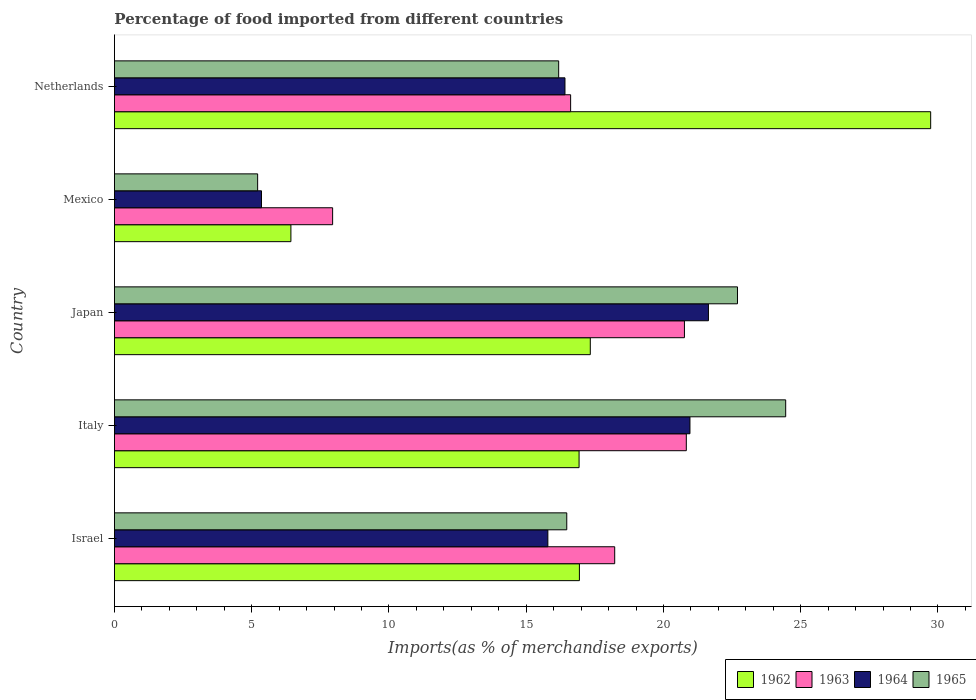How many different coloured bars are there?
Your response must be concise. 4. Are the number of bars on each tick of the Y-axis equal?
Offer a very short reply. Yes. How many bars are there on the 2nd tick from the top?
Give a very brief answer. 4. How many bars are there on the 3rd tick from the bottom?
Give a very brief answer. 4. In how many cases, is the number of bars for a given country not equal to the number of legend labels?
Give a very brief answer. 0. What is the percentage of imports to different countries in 1963 in Israel?
Offer a terse response. 18.22. Across all countries, what is the maximum percentage of imports to different countries in 1965?
Your response must be concise. 24.45. Across all countries, what is the minimum percentage of imports to different countries in 1965?
Ensure brevity in your answer.  5.22. In which country was the percentage of imports to different countries in 1965 minimum?
Offer a very short reply. Mexico. What is the total percentage of imports to different countries in 1964 in the graph?
Provide a succinct answer. 80.16. What is the difference between the percentage of imports to different countries in 1962 in Mexico and that in Netherlands?
Keep it short and to the point. -23.31. What is the difference between the percentage of imports to different countries in 1965 in Italy and the percentage of imports to different countries in 1964 in Netherlands?
Your answer should be very brief. 8.04. What is the average percentage of imports to different countries in 1965 per country?
Provide a short and direct response. 17.01. What is the difference between the percentage of imports to different countries in 1962 and percentage of imports to different countries in 1963 in Italy?
Your answer should be very brief. -3.91. What is the ratio of the percentage of imports to different countries in 1964 in Israel to that in Mexico?
Your answer should be very brief. 2.95. What is the difference between the highest and the second highest percentage of imports to different countries in 1965?
Provide a succinct answer. 1.76. What is the difference between the highest and the lowest percentage of imports to different countries in 1965?
Ensure brevity in your answer.  19.24. In how many countries, is the percentage of imports to different countries in 1962 greater than the average percentage of imports to different countries in 1962 taken over all countries?
Ensure brevity in your answer.  1. What does the 3rd bar from the top in Netherlands represents?
Provide a succinct answer. 1963. What does the 3rd bar from the bottom in Mexico represents?
Make the answer very short. 1964. How many bars are there?
Your response must be concise. 20. Are all the bars in the graph horizontal?
Give a very brief answer. Yes. Are the values on the major ticks of X-axis written in scientific E-notation?
Make the answer very short. No. Does the graph contain grids?
Offer a very short reply. No. Where does the legend appear in the graph?
Your response must be concise. Bottom right. How many legend labels are there?
Give a very brief answer. 4. How are the legend labels stacked?
Make the answer very short. Horizontal. What is the title of the graph?
Your response must be concise. Percentage of food imported from different countries. What is the label or title of the X-axis?
Provide a short and direct response. Imports(as % of merchandise exports). What is the label or title of the Y-axis?
Ensure brevity in your answer.  Country. What is the Imports(as % of merchandise exports) in 1962 in Israel?
Give a very brief answer. 16.94. What is the Imports(as % of merchandise exports) of 1963 in Israel?
Your answer should be very brief. 18.22. What is the Imports(as % of merchandise exports) of 1964 in Israel?
Your answer should be compact. 15.79. What is the Imports(as % of merchandise exports) of 1965 in Israel?
Ensure brevity in your answer.  16.48. What is the Imports(as % of merchandise exports) in 1962 in Italy?
Your answer should be very brief. 16.93. What is the Imports(as % of merchandise exports) of 1963 in Italy?
Your answer should be very brief. 20.83. What is the Imports(as % of merchandise exports) of 1964 in Italy?
Make the answer very short. 20.97. What is the Imports(as % of merchandise exports) of 1965 in Italy?
Give a very brief answer. 24.45. What is the Imports(as % of merchandise exports) in 1962 in Japan?
Provide a succinct answer. 17.34. What is the Imports(as % of merchandise exports) in 1963 in Japan?
Your response must be concise. 20.76. What is the Imports(as % of merchandise exports) of 1964 in Japan?
Provide a short and direct response. 21.64. What is the Imports(as % of merchandise exports) of 1965 in Japan?
Ensure brevity in your answer.  22.7. What is the Imports(as % of merchandise exports) of 1962 in Mexico?
Provide a short and direct response. 6.43. What is the Imports(as % of merchandise exports) in 1963 in Mexico?
Your answer should be compact. 7.95. What is the Imports(as % of merchandise exports) of 1964 in Mexico?
Give a very brief answer. 5.36. What is the Imports(as % of merchandise exports) of 1965 in Mexico?
Your answer should be compact. 5.22. What is the Imports(as % of merchandise exports) of 1962 in Netherlands?
Your response must be concise. 29.73. What is the Imports(as % of merchandise exports) of 1963 in Netherlands?
Offer a terse response. 16.62. What is the Imports(as % of merchandise exports) of 1964 in Netherlands?
Offer a very short reply. 16.41. What is the Imports(as % of merchandise exports) of 1965 in Netherlands?
Offer a very short reply. 16.18. Across all countries, what is the maximum Imports(as % of merchandise exports) in 1962?
Provide a short and direct response. 29.73. Across all countries, what is the maximum Imports(as % of merchandise exports) of 1963?
Offer a very short reply. 20.83. Across all countries, what is the maximum Imports(as % of merchandise exports) of 1964?
Your answer should be very brief. 21.64. Across all countries, what is the maximum Imports(as % of merchandise exports) of 1965?
Offer a very short reply. 24.45. Across all countries, what is the minimum Imports(as % of merchandise exports) in 1962?
Give a very brief answer. 6.43. Across all countries, what is the minimum Imports(as % of merchandise exports) of 1963?
Your response must be concise. 7.95. Across all countries, what is the minimum Imports(as % of merchandise exports) of 1964?
Provide a short and direct response. 5.36. Across all countries, what is the minimum Imports(as % of merchandise exports) of 1965?
Provide a succinct answer. 5.22. What is the total Imports(as % of merchandise exports) in 1962 in the graph?
Ensure brevity in your answer.  87.36. What is the total Imports(as % of merchandise exports) of 1963 in the graph?
Offer a terse response. 84.39. What is the total Imports(as % of merchandise exports) of 1964 in the graph?
Make the answer very short. 80.16. What is the total Imports(as % of merchandise exports) of 1965 in the graph?
Give a very brief answer. 85.03. What is the difference between the Imports(as % of merchandise exports) of 1962 in Israel and that in Italy?
Ensure brevity in your answer.  0.01. What is the difference between the Imports(as % of merchandise exports) in 1963 in Israel and that in Italy?
Your answer should be very brief. -2.61. What is the difference between the Imports(as % of merchandise exports) in 1964 in Israel and that in Italy?
Provide a succinct answer. -5.18. What is the difference between the Imports(as % of merchandise exports) in 1965 in Israel and that in Italy?
Keep it short and to the point. -7.97. What is the difference between the Imports(as % of merchandise exports) in 1962 in Israel and that in Japan?
Provide a short and direct response. -0.4. What is the difference between the Imports(as % of merchandise exports) of 1963 in Israel and that in Japan?
Keep it short and to the point. -2.54. What is the difference between the Imports(as % of merchandise exports) in 1964 in Israel and that in Japan?
Your answer should be very brief. -5.85. What is the difference between the Imports(as % of merchandise exports) of 1965 in Israel and that in Japan?
Ensure brevity in your answer.  -6.22. What is the difference between the Imports(as % of merchandise exports) of 1962 in Israel and that in Mexico?
Provide a short and direct response. 10.51. What is the difference between the Imports(as % of merchandise exports) of 1963 in Israel and that in Mexico?
Give a very brief answer. 10.28. What is the difference between the Imports(as % of merchandise exports) of 1964 in Israel and that in Mexico?
Make the answer very short. 10.43. What is the difference between the Imports(as % of merchandise exports) of 1965 in Israel and that in Mexico?
Your answer should be compact. 11.26. What is the difference between the Imports(as % of merchandise exports) of 1962 in Israel and that in Netherlands?
Make the answer very short. -12.8. What is the difference between the Imports(as % of merchandise exports) in 1963 in Israel and that in Netherlands?
Keep it short and to the point. 1.61. What is the difference between the Imports(as % of merchandise exports) of 1964 in Israel and that in Netherlands?
Give a very brief answer. -0.62. What is the difference between the Imports(as % of merchandise exports) of 1965 in Israel and that in Netherlands?
Give a very brief answer. 0.3. What is the difference between the Imports(as % of merchandise exports) of 1962 in Italy and that in Japan?
Offer a terse response. -0.41. What is the difference between the Imports(as % of merchandise exports) of 1963 in Italy and that in Japan?
Keep it short and to the point. 0.07. What is the difference between the Imports(as % of merchandise exports) of 1964 in Italy and that in Japan?
Make the answer very short. -0.67. What is the difference between the Imports(as % of merchandise exports) in 1965 in Italy and that in Japan?
Keep it short and to the point. 1.76. What is the difference between the Imports(as % of merchandise exports) of 1962 in Italy and that in Mexico?
Your answer should be very brief. 10.5. What is the difference between the Imports(as % of merchandise exports) of 1963 in Italy and that in Mexico?
Ensure brevity in your answer.  12.88. What is the difference between the Imports(as % of merchandise exports) of 1964 in Italy and that in Mexico?
Your answer should be compact. 15.61. What is the difference between the Imports(as % of merchandise exports) in 1965 in Italy and that in Mexico?
Provide a short and direct response. 19.24. What is the difference between the Imports(as % of merchandise exports) of 1962 in Italy and that in Netherlands?
Your answer should be compact. -12.81. What is the difference between the Imports(as % of merchandise exports) of 1963 in Italy and that in Netherlands?
Make the answer very short. 4.21. What is the difference between the Imports(as % of merchandise exports) of 1964 in Italy and that in Netherlands?
Make the answer very short. 4.55. What is the difference between the Imports(as % of merchandise exports) in 1965 in Italy and that in Netherlands?
Your answer should be compact. 8.27. What is the difference between the Imports(as % of merchandise exports) in 1962 in Japan and that in Mexico?
Your response must be concise. 10.91. What is the difference between the Imports(as % of merchandise exports) in 1963 in Japan and that in Mexico?
Your answer should be very brief. 12.82. What is the difference between the Imports(as % of merchandise exports) of 1964 in Japan and that in Mexico?
Offer a very short reply. 16.28. What is the difference between the Imports(as % of merchandise exports) of 1965 in Japan and that in Mexico?
Offer a terse response. 17.48. What is the difference between the Imports(as % of merchandise exports) of 1962 in Japan and that in Netherlands?
Offer a terse response. -12.4. What is the difference between the Imports(as % of merchandise exports) of 1963 in Japan and that in Netherlands?
Your answer should be very brief. 4.15. What is the difference between the Imports(as % of merchandise exports) in 1964 in Japan and that in Netherlands?
Provide a succinct answer. 5.23. What is the difference between the Imports(as % of merchandise exports) of 1965 in Japan and that in Netherlands?
Your answer should be very brief. 6.51. What is the difference between the Imports(as % of merchandise exports) of 1962 in Mexico and that in Netherlands?
Keep it short and to the point. -23.31. What is the difference between the Imports(as % of merchandise exports) in 1963 in Mexico and that in Netherlands?
Provide a short and direct response. -8.67. What is the difference between the Imports(as % of merchandise exports) of 1964 in Mexico and that in Netherlands?
Your answer should be very brief. -11.05. What is the difference between the Imports(as % of merchandise exports) in 1965 in Mexico and that in Netherlands?
Offer a very short reply. -10.97. What is the difference between the Imports(as % of merchandise exports) in 1962 in Israel and the Imports(as % of merchandise exports) in 1963 in Italy?
Keep it short and to the point. -3.89. What is the difference between the Imports(as % of merchandise exports) of 1962 in Israel and the Imports(as % of merchandise exports) of 1964 in Italy?
Give a very brief answer. -4.03. What is the difference between the Imports(as % of merchandise exports) of 1962 in Israel and the Imports(as % of merchandise exports) of 1965 in Italy?
Your answer should be very brief. -7.51. What is the difference between the Imports(as % of merchandise exports) in 1963 in Israel and the Imports(as % of merchandise exports) in 1964 in Italy?
Make the answer very short. -2.74. What is the difference between the Imports(as % of merchandise exports) of 1963 in Israel and the Imports(as % of merchandise exports) of 1965 in Italy?
Provide a short and direct response. -6.23. What is the difference between the Imports(as % of merchandise exports) in 1964 in Israel and the Imports(as % of merchandise exports) in 1965 in Italy?
Ensure brevity in your answer.  -8.66. What is the difference between the Imports(as % of merchandise exports) of 1962 in Israel and the Imports(as % of merchandise exports) of 1963 in Japan?
Your answer should be very brief. -3.83. What is the difference between the Imports(as % of merchandise exports) of 1962 in Israel and the Imports(as % of merchandise exports) of 1964 in Japan?
Your answer should be compact. -4.7. What is the difference between the Imports(as % of merchandise exports) in 1962 in Israel and the Imports(as % of merchandise exports) in 1965 in Japan?
Provide a short and direct response. -5.76. What is the difference between the Imports(as % of merchandise exports) in 1963 in Israel and the Imports(as % of merchandise exports) in 1964 in Japan?
Your answer should be compact. -3.41. What is the difference between the Imports(as % of merchandise exports) of 1963 in Israel and the Imports(as % of merchandise exports) of 1965 in Japan?
Provide a succinct answer. -4.47. What is the difference between the Imports(as % of merchandise exports) in 1964 in Israel and the Imports(as % of merchandise exports) in 1965 in Japan?
Offer a very short reply. -6.91. What is the difference between the Imports(as % of merchandise exports) in 1962 in Israel and the Imports(as % of merchandise exports) in 1963 in Mexico?
Make the answer very short. 8.99. What is the difference between the Imports(as % of merchandise exports) of 1962 in Israel and the Imports(as % of merchandise exports) of 1964 in Mexico?
Your response must be concise. 11.58. What is the difference between the Imports(as % of merchandise exports) in 1962 in Israel and the Imports(as % of merchandise exports) in 1965 in Mexico?
Offer a very short reply. 11.72. What is the difference between the Imports(as % of merchandise exports) of 1963 in Israel and the Imports(as % of merchandise exports) of 1964 in Mexico?
Provide a short and direct response. 12.87. What is the difference between the Imports(as % of merchandise exports) in 1963 in Israel and the Imports(as % of merchandise exports) in 1965 in Mexico?
Your response must be concise. 13.01. What is the difference between the Imports(as % of merchandise exports) in 1964 in Israel and the Imports(as % of merchandise exports) in 1965 in Mexico?
Give a very brief answer. 10.57. What is the difference between the Imports(as % of merchandise exports) of 1962 in Israel and the Imports(as % of merchandise exports) of 1963 in Netherlands?
Your answer should be compact. 0.32. What is the difference between the Imports(as % of merchandise exports) of 1962 in Israel and the Imports(as % of merchandise exports) of 1964 in Netherlands?
Ensure brevity in your answer.  0.53. What is the difference between the Imports(as % of merchandise exports) in 1962 in Israel and the Imports(as % of merchandise exports) in 1965 in Netherlands?
Offer a very short reply. 0.76. What is the difference between the Imports(as % of merchandise exports) of 1963 in Israel and the Imports(as % of merchandise exports) of 1964 in Netherlands?
Give a very brief answer. 1.81. What is the difference between the Imports(as % of merchandise exports) of 1963 in Israel and the Imports(as % of merchandise exports) of 1965 in Netherlands?
Your answer should be compact. 2.04. What is the difference between the Imports(as % of merchandise exports) of 1964 in Israel and the Imports(as % of merchandise exports) of 1965 in Netherlands?
Your answer should be compact. -0.39. What is the difference between the Imports(as % of merchandise exports) of 1962 in Italy and the Imports(as % of merchandise exports) of 1963 in Japan?
Provide a short and direct response. -3.84. What is the difference between the Imports(as % of merchandise exports) of 1962 in Italy and the Imports(as % of merchandise exports) of 1964 in Japan?
Keep it short and to the point. -4.71. What is the difference between the Imports(as % of merchandise exports) in 1962 in Italy and the Imports(as % of merchandise exports) in 1965 in Japan?
Your answer should be compact. -5.77. What is the difference between the Imports(as % of merchandise exports) in 1963 in Italy and the Imports(as % of merchandise exports) in 1964 in Japan?
Make the answer very short. -0.81. What is the difference between the Imports(as % of merchandise exports) in 1963 in Italy and the Imports(as % of merchandise exports) in 1965 in Japan?
Give a very brief answer. -1.86. What is the difference between the Imports(as % of merchandise exports) in 1964 in Italy and the Imports(as % of merchandise exports) in 1965 in Japan?
Offer a terse response. -1.73. What is the difference between the Imports(as % of merchandise exports) in 1962 in Italy and the Imports(as % of merchandise exports) in 1963 in Mexico?
Offer a very short reply. 8.98. What is the difference between the Imports(as % of merchandise exports) in 1962 in Italy and the Imports(as % of merchandise exports) in 1964 in Mexico?
Your answer should be very brief. 11.57. What is the difference between the Imports(as % of merchandise exports) in 1962 in Italy and the Imports(as % of merchandise exports) in 1965 in Mexico?
Your answer should be very brief. 11.71. What is the difference between the Imports(as % of merchandise exports) in 1963 in Italy and the Imports(as % of merchandise exports) in 1964 in Mexico?
Provide a succinct answer. 15.48. What is the difference between the Imports(as % of merchandise exports) in 1963 in Italy and the Imports(as % of merchandise exports) in 1965 in Mexico?
Provide a short and direct response. 15.62. What is the difference between the Imports(as % of merchandise exports) in 1964 in Italy and the Imports(as % of merchandise exports) in 1965 in Mexico?
Your answer should be very brief. 15.75. What is the difference between the Imports(as % of merchandise exports) of 1962 in Italy and the Imports(as % of merchandise exports) of 1963 in Netherlands?
Your answer should be compact. 0.31. What is the difference between the Imports(as % of merchandise exports) in 1962 in Italy and the Imports(as % of merchandise exports) in 1964 in Netherlands?
Your answer should be compact. 0.51. What is the difference between the Imports(as % of merchandise exports) of 1962 in Italy and the Imports(as % of merchandise exports) of 1965 in Netherlands?
Provide a succinct answer. 0.74. What is the difference between the Imports(as % of merchandise exports) of 1963 in Italy and the Imports(as % of merchandise exports) of 1964 in Netherlands?
Offer a very short reply. 4.42. What is the difference between the Imports(as % of merchandise exports) of 1963 in Italy and the Imports(as % of merchandise exports) of 1965 in Netherlands?
Offer a very short reply. 4.65. What is the difference between the Imports(as % of merchandise exports) in 1964 in Italy and the Imports(as % of merchandise exports) in 1965 in Netherlands?
Give a very brief answer. 4.78. What is the difference between the Imports(as % of merchandise exports) of 1962 in Japan and the Imports(as % of merchandise exports) of 1963 in Mexico?
Your answer should be very brief. 9.39. What is the difference between the Imports(as % of merchandise exports) in 1962 in Japan and the Imports(as % of merchandise exports) in 1964 in Mexico?
Make the answer very short. 11.98. What is the difference between the Imports(as % of merchandise exports) in 1962 in Japan and the Imports(as % of merchandise exports) in 1965 in Mexico?
Your response must be concise. 12.12. What is the difference between the Imports(as % of merchandise exports) in 1963 in Japan and the Imports(as % of merchandise exports) in 1964 in Mexico?
Your response must be concise. 15.41. What is the difference between the Imports(as % of merchandise exports) of 1963 in Japan and the Imports(as % of merchandise exports) of 1965 in Mexico?
Provide a succinct answer. 15.55. What is the difference between the Imports(as % of merchandise exports) in 1964 in Japan and the Imports(as % of merchandise exports) in 1965 in Mexico?
Your answer should be very brief. 16.42. What is the difference between the Imports(as % of merchandise exports) in 1962 in Japan and the Imports(as % of merchandise exports) in 1963 in Netherlands?
Your response must be concise. 0.72. What is the difference between the Imports(as % of merchandise exports) in 1962 in Japan and the Imports(as % of merchandise exports) in 1964 in Netherlands?
Give a very brief answer. 0.92. What is the difference between the Imports(as % of merchandise exports) of 1962 in Japan and the Imports(as % of merchandise exports) of 1965 in Netherlands?
Offer a terse response. 1.15. What is the difference between the Imports(as % of merchandise exports) of 1963 in Japan and the Imports(as % of merchandise exports) of 1964 in Netherlands?
Your response must be concise. 4.35. What is the difference between the Imports(as % of merchandise exports) in 1963 in Japan and the Imports(as % of merchandise exports) in 1965 in Netherlands?
Your response must be concise. 4.58. What is the difference between the Imports(as % of merchandise exports) of 1964 in Japan and the Imports(as % of merchandise exports) of 1965 in Netherlands?
Keep it short and to the point. 5.46. What is the difference between the Imports(as % of merchandise exports) in 1962 in Mexico and the Imports(as % of merchandise exports) in 1963 in Netherlands?
Keep it short and to the point. -10.19. What is the difference between the Imports(as % of merchandise exports) of 1962 in Mexico and the Imports(as % of merchandise exports) of 1964 in Netherlands?
Keep it short and to the point. -9.98. What is the difference between the Imports(as % of merchandise exports) in 1962 in Mexico and the Imports(as % of merchandise exports) in 1965 in Netherlands?
Your response must be concise. -9.75. What is the difference between the Imports(as % of merchandise exports) of 1963 in Mexico and the Imports(as % of merchandise exports) of 1964 in Netherlands?
Keep it short and to the point. -8.46. What is the difference between the Imports(as % of merchandise exports) of 1963 in Mexico and the Imports(as % of merchandise exports) of 1965 in Netherlands?
Provide a short and direct response. -8.23. What is the difference between the Imports(as % of merchandise exports) of 1964 in Mexico and the Imports(as % of merchandise exports) of 1965 in Netherlands?
Make the answer very short. -10.83. What is the average Imports(as % of merchandise exports) of 1962 per country?
Your response must be concise. 17.47. What is the average Imports(as % of merchandise exports) in 1963 per country?
Make the answer very short. 16.88. What is the average Imports(as % of merchandise exports) in 1964 per country?
Your response must be concise. 16.03. What is the average Imports(as % of merchandise exports) in 1965 per country?
Provide a short and direct response. 17.01. What is the difference between the Imports(as % of merchandise exports) in 1962 and Imports(as % of merchandise exports) in 1963 in Israel?
Offer a terse response. -1.29. What is the difference between the Imports(as % of merchandise exports) of 1962 and Imports(as % of merchandise exports) of 1964 in Israel?
Make the answer very short. 1.15. What is the difference between the Imports(as % of merchandise exports) in 1962 and Imports(as % of merchandise exports) in 1965 in Israel?
Keep it short and to the point. 0.46. What is the difference between the Imports(as % of merchandise exports) in 1963 and Imports(as % of merchandise exports) in 1964 in Israel?
Offer a terse response. 2.43. What is the difference between the Imports(as % of merchandise exports) of 1963 and Imports(as % of merchandise exports) of 1965 in Israel?
Provide a succinct answer. 1.75. What is the difference between the Imports(as % of merchandise exports) in 1964 and Imports(as % of merchandise exports) in 1965 in Israel?
Your response must be concise. -0.69. What is the difference between the Imports(as % of merchandise exports) of 1962 and Imports(as % of merchandise exports) of 1963 in Italy?
Give a very brief answer. -3.91. What is the difference between the Imports(as % of merchandise exports) in 1962 and Imports(as % of merchandise exports) in 1964 in Italy?
Ensure brevity in your answer.  -4.04. What is the difference between the Imports(as % of merchandise exports) in 1962 and Imports(as % of merchandise exports) in 1965 in Italy?
Your response must be concise. -7.53. What is the difference between the Imports(as % of merchandise exports) of 1963 and Imports(as % of merchandise exports) of 1964 in Italy?
Make the answer very short. -0.13. What is the difference between the Imports(as % of merchandise exports) in 1963 and Imports(as % of merchandise exports) in 1965 in Italy?
Your answer should be compact. -3.62. What is the difference between the Imports(as % of merchandise exports) in 1964 and Imports(as % of merchandise exports) in 1965 in Italy?
Ensure brevity in your answer.  -3.49. What is the difference between the Imports(as % of merchandise exports) of 1962 and Imports(as % of merchandise exports) of 1963 in Japan?
Your answer should be very brief. -3.43. What is the difference between the Imports(as % of merchandise exports) of 1962 and Imports(as % of merchandise exports) of 1964 in Japan?
Make the answer very short. -4.3. What is the difference between the Imports(as % of merchandise exports) of 1962 and Imports(as % of merchandise exports) of 1965 in Japan?
Give a very brief answer. -5.36. What is the difference between the Imports(as % of merchandise exports) of 1963 and Imports(as % of merchandise exports) of 1964 in Japan?
Your response must be concise. -0.87. What is the difference between the Imports(as % of merchandise exports) in 1963 and Imports(as % of merchandise exports) in 1965 in Japan?
Offer a very short reply. -1.93. What is the difference between the Imports(as % of merchandise exports) of 1964 and Imports(as % of merchandise exports) of 1965 in Japan?
Make the answer very short. -1.06. What is the difference between the Imports(as % of merchandise exports) in 1962 and Imports(as % of merchandise exports) in 1963 in Mexico?
Offer a terse response. -1.52. What is the difference between the Imports(as % of merchandise exports) of 1962 and Imports(as % of merchandise exports) of 1964 in Mexico?
Provide a succinct answer. 1.07. What is the difference between the Imports(as % of merchandise exports) of 1962 and Imports(as % of merchandise exports) of 1965 in Mexico?
Offer a very short reply. 1.21. What is the difference between the Imports(as % of merchandise exports) in 1963 and Imports(as % of merchandise exports) in 1964 in Mexico?
Offer a terse response. 2.59. What is the difference between the Imports(as % of merchandise exports) of 1963 and Imports(as % of merchandise exports) of 1965 in Mexico?
Make the answer very short. 2.73. What is the difference between the Imports(as % of merchandise exports) in 1964 and Imports(as % of merchandise exports) in 1965 in Mexico?
Your response must be concise. 0.14. What is the difference between the Imports(as % of merchandise exports) in 1962 and Imports(as % of merchandise exports) in 1963 in Netherlands?
Offer a very short reply. 13.12. What is the difference between the Imports(as % of merchandise exports) in 1962 and Imports(as % of merchandise exports) in 1964 in Netherlands?
Provide a succinct answer. 13.32. What is the difference between the Imports(as % of merchandise exports) of 1962 and Imports(as % of merchandise exports) of 1965 in Netherlands?
Provide a succinct answer. 13.55. What is the difference between the Imports(as % of merchandise exports) of 1963 and Imports(as % of merchandise exports) of 1964 in Netherlands?
Your response must be concise. 0.21. What is the difference between the Imports(as % of merchandise exports) of 1963 and Imports(as % of merchandise exports) of 1965 in Netherlands?
Your response must be concise. 0.44. What is the difference between the Imports(as % of merchandise exports) in 1964 and Imports(as % of merchandise exports) in 1965 in Netherlands?
Provide a short and direct response. 0.23. What is the ratio of the Imports(as % of merchandise exports) of 1963 in Israel to that in Italy?
Offer a very short reply. 0.87. What is the ratio of the Imports(as % of merchandise exports) in 1964 in Israel to that in Italy?
Your answer should be compact. 0.75. What is the ratio of the Imports(as % of merchandise exports) in 1965 in Israel to that in Italy?
Ensure brevity in your answer.  0.67. What is the ratio of the Imports(as % of merchandise exports) of 1962 in Israel to that in Japan?
Ensure brevity in your answer.  0.98. What is the ratio of the Imports(as % of merchandise exports) in 1963 in Israel to that in Japan?
Ensure brevity in your answer.  0.88. What is the ratio of the Imports(as % of merchandise exports) in 1964 in Israel to that in Japan?
Keep it short and to the point. 0.73. What is the ratio of the Imports(as % of merchandise exports) in 1965 in Israel to that in Japan?
Your answer should be compact. 0.73. What is the ratio of the Imports(as % of merchandise exports) in 1962 in Israel to that in Mexico?
Your answer should be compact. 2.63. What is the ratio of the Imports(as % of merchandise exports) of 1963 in Israel to that in Mexico?
Provide a short and direct response. 2.29. What is the ratio of the Imports(as % of merchandise exports) in 1964 in Israel to that in Mexico?
Ensure brevity in your answer.  2.95. What is the ratio of the Imports(as % of merchandise exports) in 1965 in Israel to that in Mexico?
Your answer should be compact. 3.16. What is the ratio of the Imports(as % of merchandise exports) in 1962 in Israel to that in Netherlands?
Your answer should be compact. 0.57. What is the ratio of the Imports(as % of merchandise exports) of 1963 in Israel to that in Netherlands?
Ensure brevity in your answer.  1.1. What is the ratio of the Imports(as % of merchandise exports) in 1965 in Israel to that in Netherlands?
Provide a succinct answer. 1.02. What is the ratio of the Imports(as % of merchandise exports) of 1962 in Italy to that in Japan?
Offer a very short reply. 0.98. What is the ratio of the Imports(as % of merchandise exports) of 1964 in Italy to that in Japan?
Provide a succinct answer. 0.97. What is the ratio of the Imports(as % of merchandise exports) in 1965 in Italy to that in Japan?
Keep it short and to the point. 1.08. What is the ratio of the Imports(as % of merchandise exports) in 1962 in Italy to that in Mexico?
Provide a short and direct response. 2.63. What is the ratio of the Imports(as % of merchandise exports) in 1963 in Italy to that in Mexico?
Your response must be concise. 2.62. What is the ratio of the Imports(as % of merchandise exports) in 1964 in Italy to that in Mexico?
Provide a short and direct response. 3.91. What is the ratio of the Imports(as % of merchandise exports) in 1965 in Italy to that in Mexico?
Your answer should be very brief. 4.69. What is the ratio of the Imports(as % of merchandise exports) of 1962 in Italy to that in Netherlands?
Your response must be concise. 0.57. What is the ratio of the Imports(as % of merchandise exports) in 1963 in Italy to that in Netherlands?
Your answer should be compact. 1.25. What is the ratio of the Imports(as % of merchandise exports) in 1964 in Italy to that in Netherlands?
Provide a short and direct response. 1.28. What is the ratio of the Imports(as % of merchandise exports) in 1965 in Italy to that in Netherlands?
Make the answer very short. 1.51. What is the ratio of the Imports(as % of merchandise exports) in 1962 in Japan to that in Mexico?
Offer a terse response. 2.7. What is the ratio of the Imports(as % of merchandise exports) of 1963 in Japan to that in Mexico?
Provide a succinct answer. 2.61. What is the ratio of the Imports(as % of merchandise exports) of 1964 in Japan to that in Mexico?
Provide a succinct answer. 4.04. What is the ratio of the Imports(as % of merchandise exports) of 1965 in Japan to that in Mexico?
Ensure brevity in your answer.  4.35. What is the ratio of the Imports(as % of merchandise exports) of 1962 in Japan to that in Netherlands?
Offer a terse response. 0.58. What is the ratio of the Imports(as % of merchandise exports) in 1963 in Japan to that in Netherlands?
Give a very brief answer. 1.25. What is the ratio of the Imports(as % of merchandise exports) of 1964 in Japan to that in Netherlands?
Keep it short and to the point. 1.32. What is the ratio of the Imports(as % of merchandise exports) of 1965 in Japan to that in Netherlands?
Keep it short and to the point. 1.4. What is the ratio of the Imports(as % of merchandise exports) of 1962 in Mexico to that in Netherlands?
Offer a terse response. 0.22. What is the ratio of the Imports(as % of merchandise exports) of 1963 in Mexico to that in Netherlands?
Your answer should be compact. 0.48. What is the ratio of the Imports(as % of merchandise exports) in 1964 in Mexico to that in Netherlands?
Your response must be concise. 0.33. What is the ratio of the Imports(as % of merchandise exports) in 1965 in Mexico to that in Netherlands?
Ensure brevity in your answer.  0.32. What is the difference between the highest and the second highest Imports(as % of merchandise exports) in 1962?
Provide a short and direct response. 12.4. What is the difference between the highest and the second highest Imports(as % of merchandise exports) in 1963?
Ensure brevity in your answer.  0.07. What is the difference between the highest and the second highest Imports(as % of merchandise exports) in 1964?
Keep it short and to the point. 0.67. What is the difference between the highest and the second highest Imports(as % of merchandise exports) of 1965?
Make the answer very short. 1.76. What is the difference between the highest and the lowest Imports(as % of merchandise exports) in 1962?
Your answer should be very brief. 23.31. What is the difference between the highest and the lowest Imports(as % of merchandise exports) of 1963?
Provide a succinct answer. 12.88. What is the difference between the highest and the lowest Imports(as % of merchandise exports) of 1964?
Your response must be concise. 16.28. What is the difference between the highest and the lowest Imports(as % of merchandise exports) in 1965?
Offer a terse response. 19.24. 